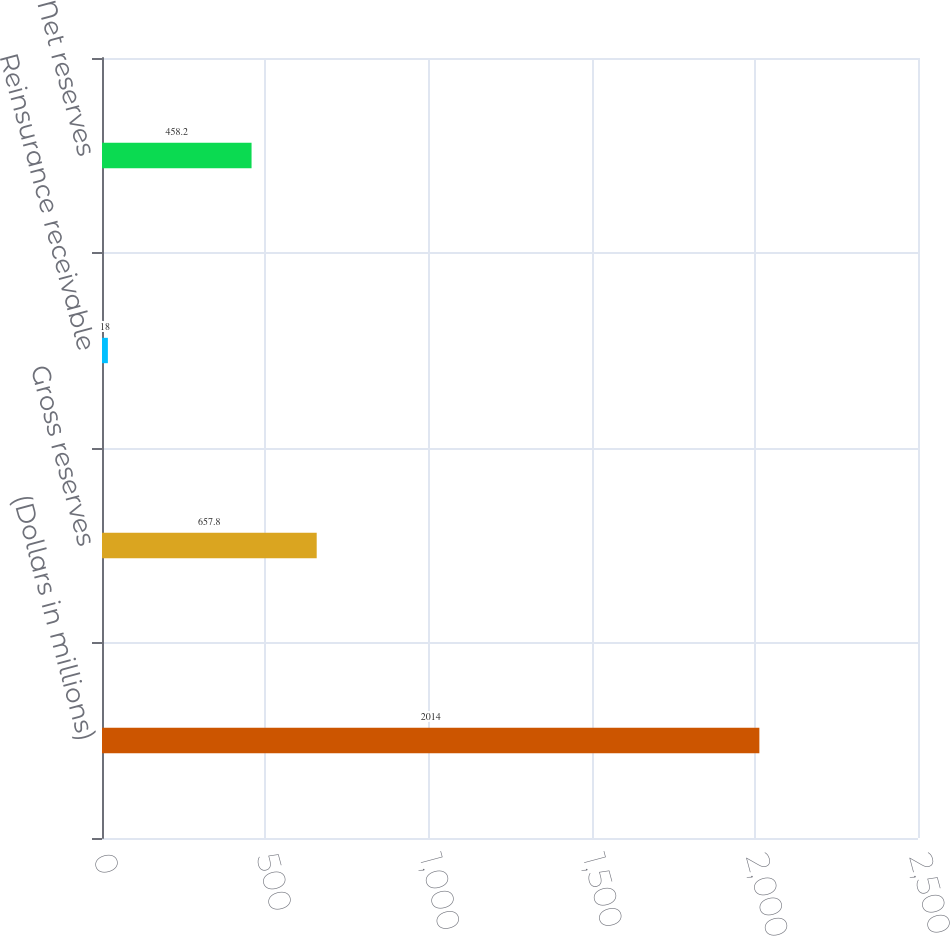Convert chart to OTSL. <chart><loc_0><loc_0><loc_500><loc_500><bar_chart><fcel>(Dollars in millions)<fcel>Gross reserves<fcel>Reinsurance receivable<fcel>Net reserves<nl><fcel>2014<fcel>657.8<fcel>18<fcel>458.2<nl></chart> 